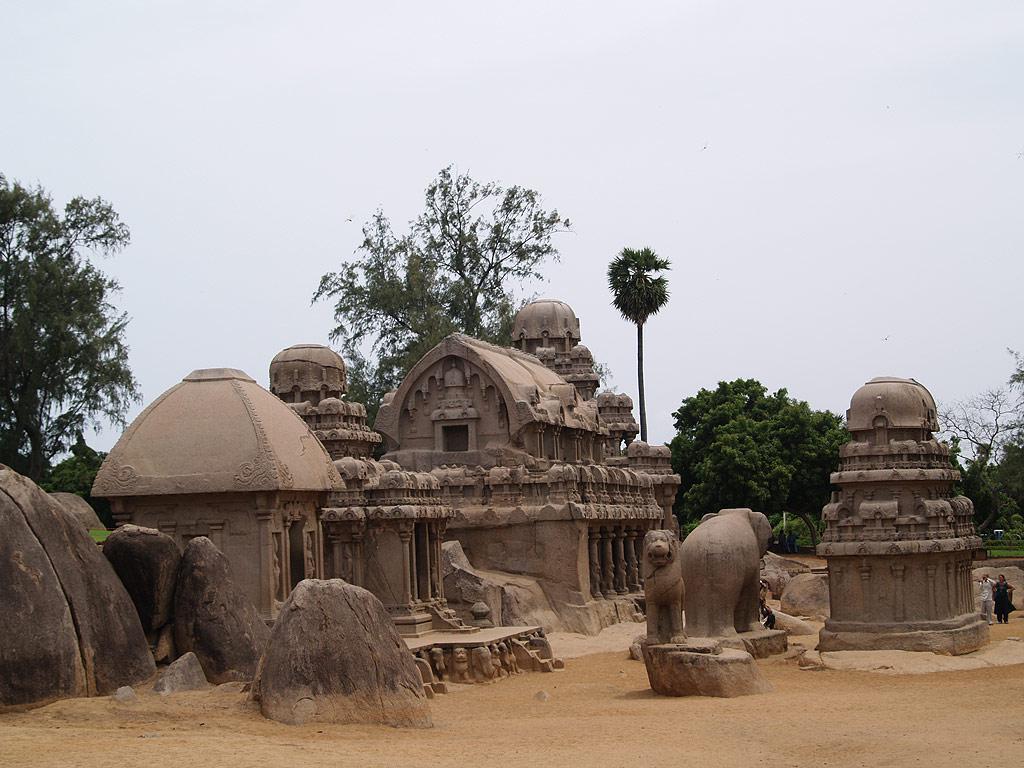Describe this image in one or two sentences. In this image we can see ancient architecture, ground, people, statues, and trees. In the background there is sky. 